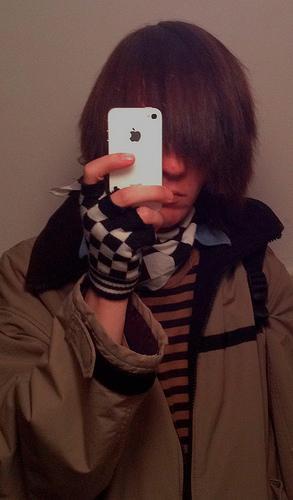How many phones are there?
Give a very brief answer. 1. 